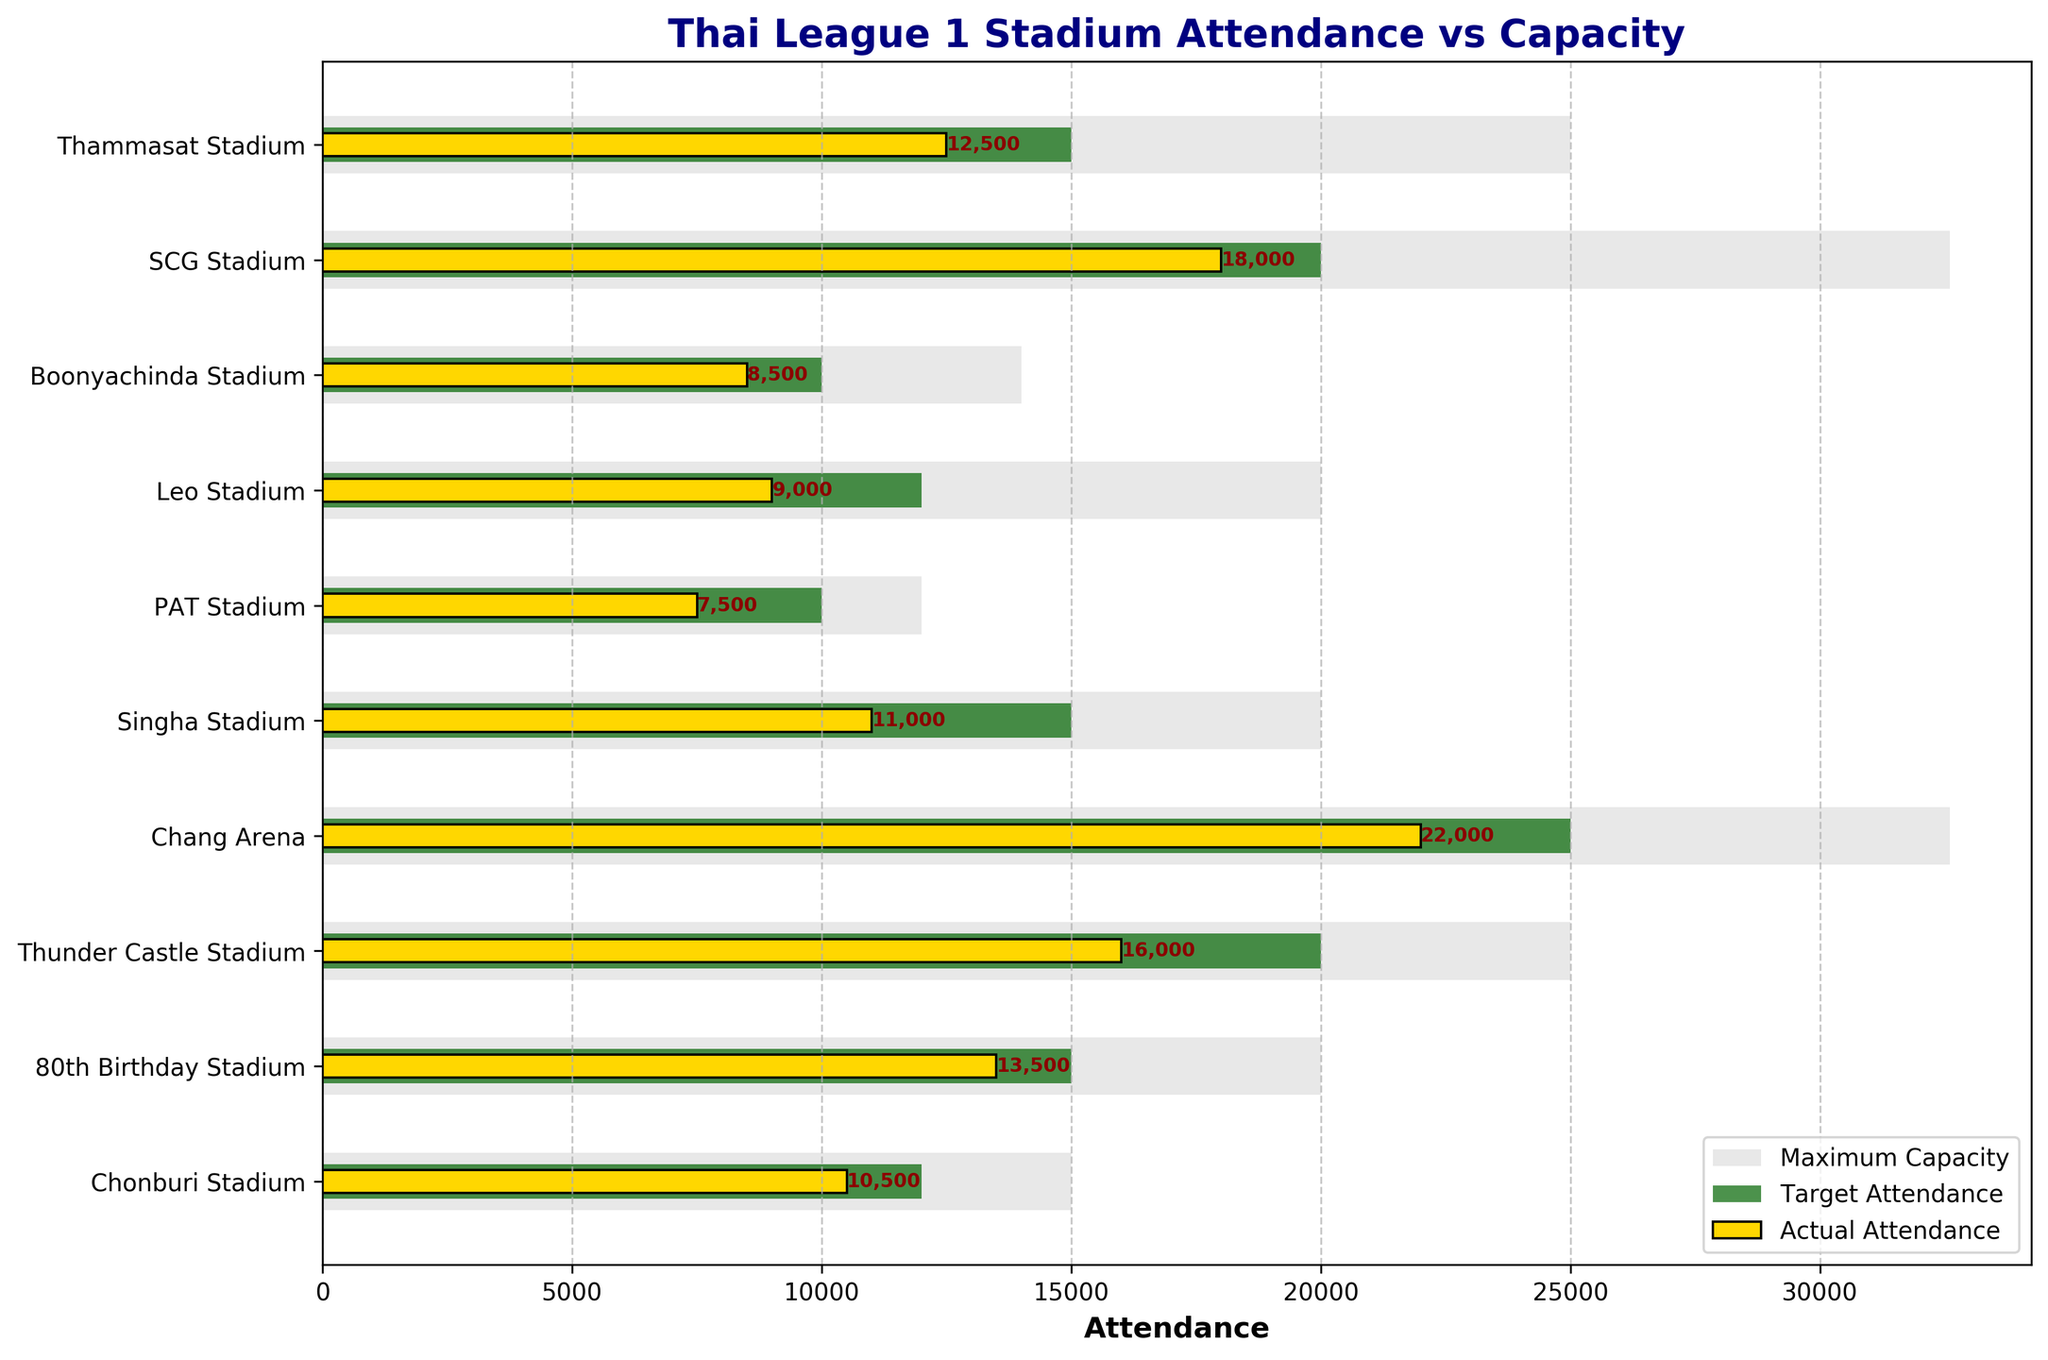what is the title of the figure? The title of the figure is located at the top center of the plot.
Answer: Thai League 1 Stadium Attendance vs Capacity How many stadiums are represented in the figure? Count the number of unique stadium names listed as y-axis labels.
Answer: 10 Which stadium has the highest actual attendance? Look for the longest yellow bar representing "Actual Attendance".
Answer: Chang Arena Is there any stadium where the actual attendance met or exceeded the target attendance? Compare the lengths of the yellow (actual) and green (target) bars for each stadium.
Answer: No Which stadium has the smallest gap between actual attendance and target attendance? Calculate the difference between the yellow (actual) and green (target) bars for each stadium and find the minimum value.
Answer: 80th Birthday Stadium How does the actual attendance at Boonyachinda Stadium compare to its maximum capacity? Compare the length of the yellow bar (actual attendance) to the length of the grey bar (maximum capacity) for Boonyachinda Stadium.
Answer: The actual attendance is less than the maximum capacity What is the average actual attendance across all stadiums? Sum the actual attendance for all stadiums and divide by the number of stadiums (10). (12500 + 18000 + 8500 + 9000 + 7500 + 11000 + 22000 + 16000 + 13500 + 10500) / 10
Answer: 12,750 Which stadium has the highest maximum capacity? Look for the longest grey bar representing "Maximum Capacity".
Answer: SCG Stadium and Chang Arena Which stadium is underperforming the most in terms of actual attendance versus target attendance? Identify the stadium with the largest negative difference between the yellow (actual) and green (target) bars.
Answer: Thunder Castle Stadium What is the median target attendance across all stadiums? List the target attendance values in ascending order and find the middle value. (10000, 10000, 10000, 12000, 12000, 15000, 15000, 20000, 20000, 25000); the median is the average of the 5th and 6th values. (12000 + 15000) / 2
Answer: 13,500 